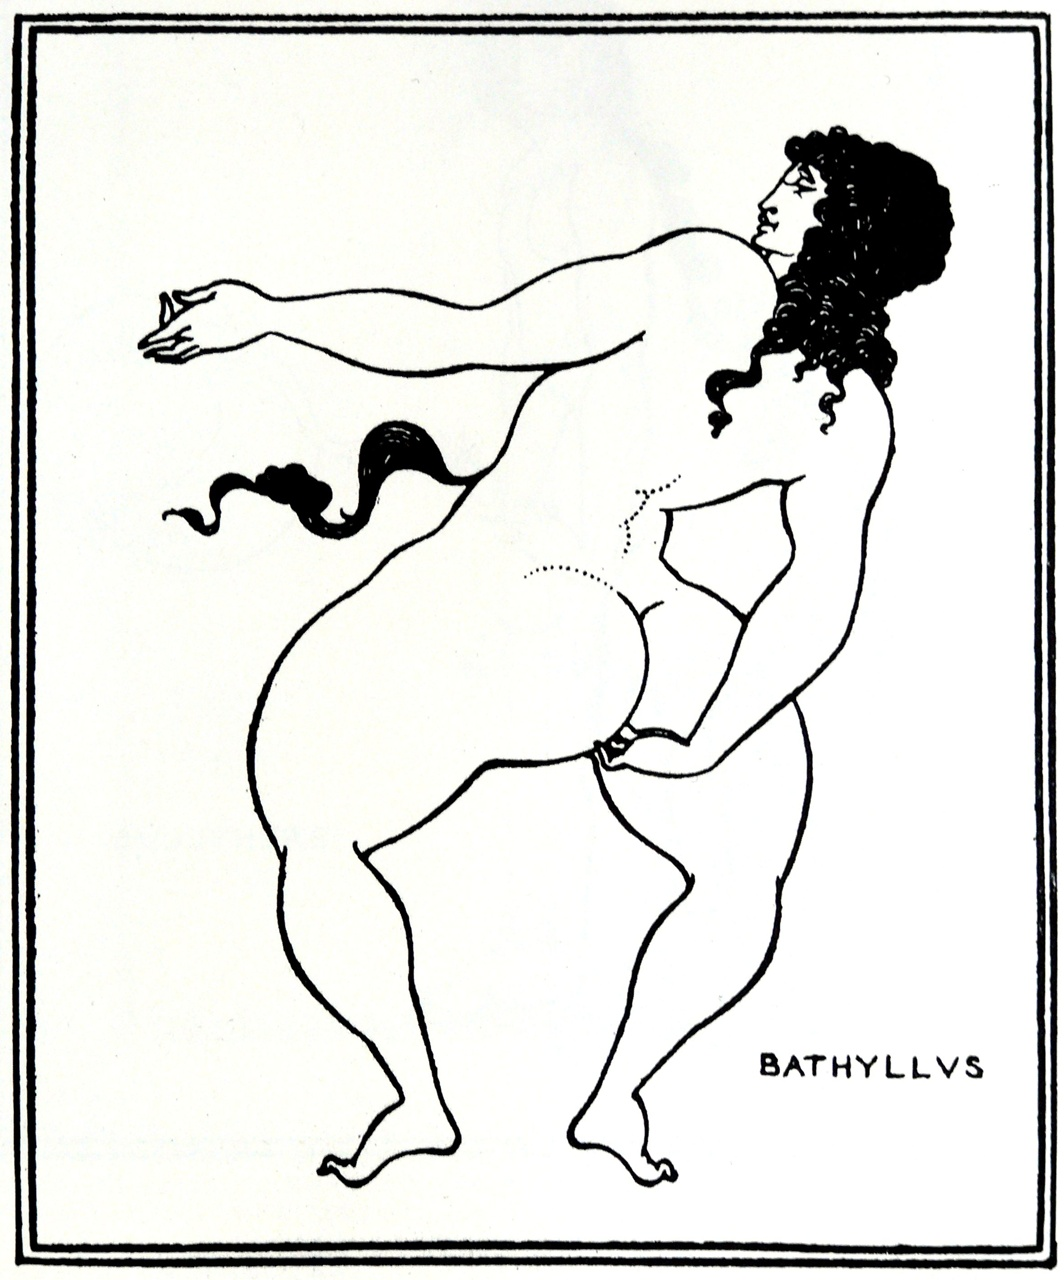Can you elaborate on the elements of the picture provided? The image exhibits a stylized figure drawn in a manner reminiscent of ancient Greek pottery art. This nude male figure, labelled 'Bathyllys', stands in a complex pose, balanced on one leg with the other raised and foot resting on the thigh, suggestive of a dance or a ritualistic stance. He holds an object in his right hand, which might be related to the activity he is engaged in, possibly a ritualistic item or a tool. The extended left arm and dynamic posture add to the narrative quality of the image, inviting interpretations related to mythology or ancient ceremonies. The use of line art technique, with clear, flowing lines and minimal detail adheres to the aesthetic of ancient black-figure vases, where such imagery was often used to depict scenes from daily life or mythology. 